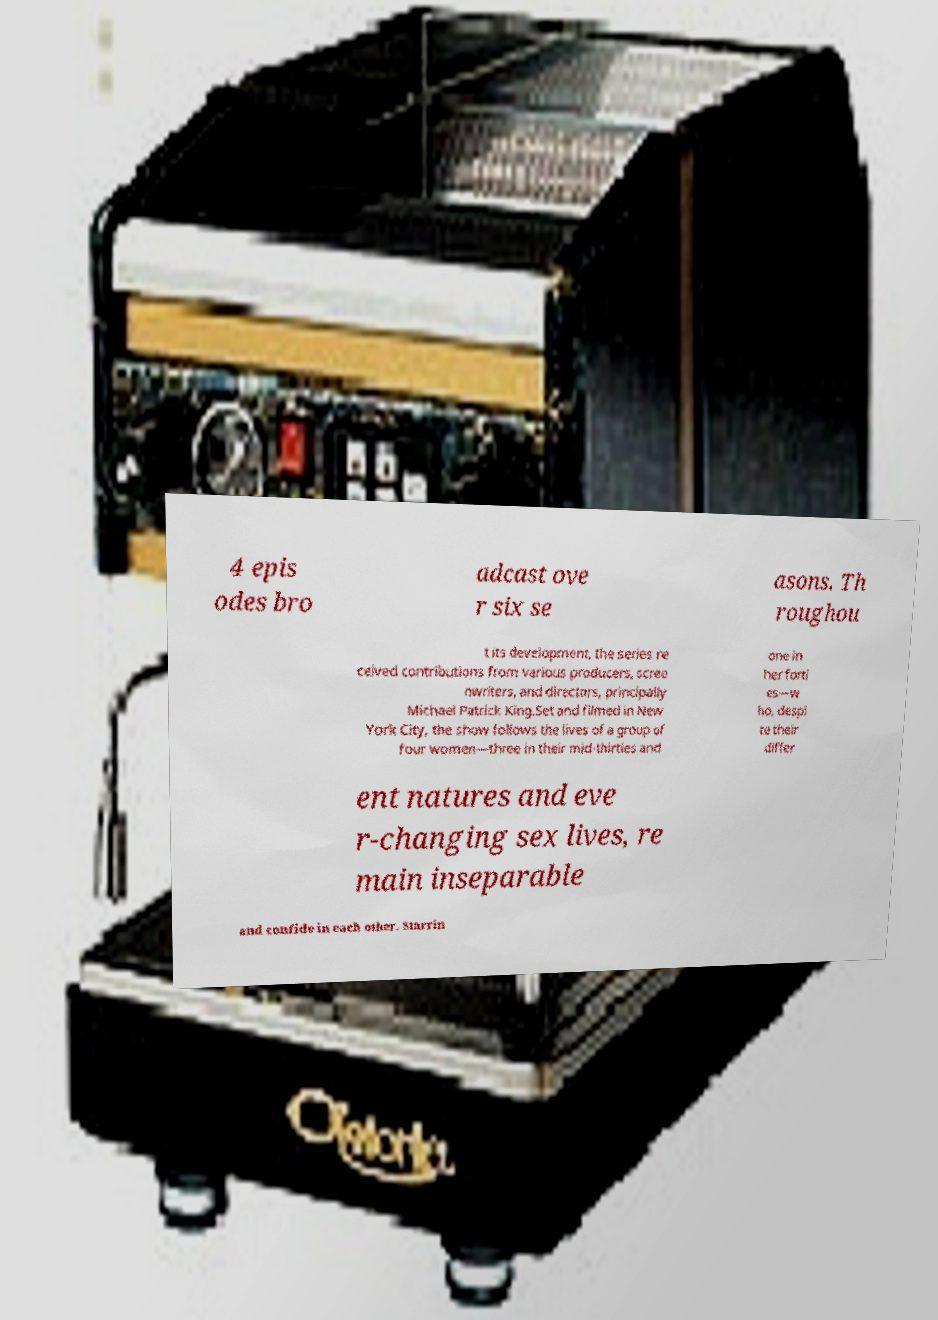Can you accurately transcribe the text from the provided image for me? 4 epis odes bro adcast ove r six se asons. Th roughou t its development, the series re ceived contributions from various producers, scree nwriters, and directors, principally Michael Patrick King.Set and filmed in New York City, the show follows the lives of a group of four women—three in their mid-thirties and one in her forti es—w ho, despi te their differ ent natures and eve r-changing sex lives, re main inseparable and confide in each other. Starrin 